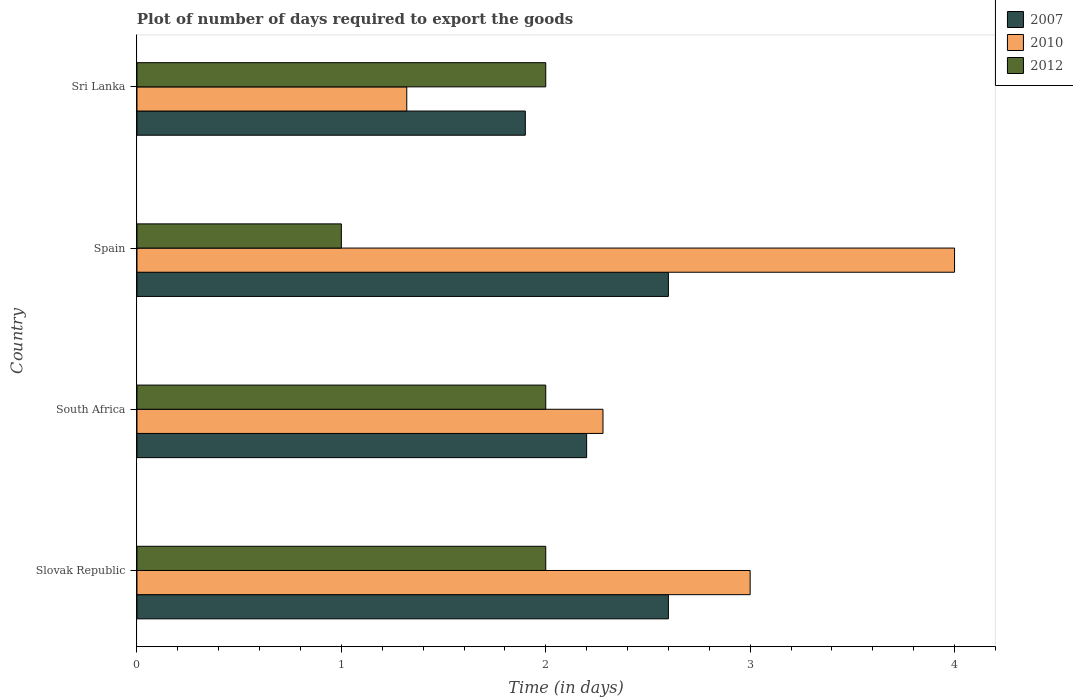How many different coloured bars are there?
Offer a terse response. 3. Are the number of bars on each tick of the Y-axis equal?
Provide a short and direct response. Yes. What is the time required to export goods in 2010 in South Africa?
Offer a very short reply. 2.28. Across all countries, what is the minimum time required to export goods in 2012?
Keep it short and to the point. 1. In which country was the time required to export goods in 2012 maximum?
Give a very brief answer. Slovak Republic. In which country was the time required to export goods in 2010 minimum?
Offer a terse response. Sri Lanka. What is the average time required to export goods in 2010 per country?
Provide a succinct answer. 2.65. In how many countries, is the time required to export goods in 2007 greater than 1.2 days?
Provide a succinct answer. 4. What is the ratio of the time required to export goods in 2007 in South Africa to that in Spain?
Provide a short and direct response. 0.85. What is the difference between the highest and the lowest time required to export goods in 2012?
Provide a succinct answer. 1. Is the sum of the time required to export goods in 2010 in South Africa and Spain greater than the maximum time required to export goods in 2012 across all countries?
Provide a succinct answer. Yes. Are all the bars in the graph horizontal?
Your answer should be compact. Yes. How many countries are there in the graph?
Ensure brevity in your answer.  4. What is the difference between two consecutive major ticks on the X-axis?
Your answer should be very brief. 1. Does the graph contain grids?
Keep it short and to the point. No. What is the title of the graph?
Provide a short and direct response. Plot of number of days required to export the goods. Does "1986" appear as one of the legend labels in the graph?
Offer a terse response. No. What is the label or title of the X-axis?
Keep it short and to the point. Time (in days). What is the Time (in days) of 2007 in Slovak Republic?
Ensure brevity in your answer.  2.6. What is the Time (in days) in 2007 in South Africa?
Offer a terse response. 2.2. What is the Time (in days) of 2010 in South Africa?
Your answer should be compact. 2.28. What is the Time (in days) in 2012 in South Africa?
Your answer should be compact. 2. What is the Time (in days) in 2007 in Sri Lanka?
Ensure brevity in your answer.  1.9. What is the Time (in days) of 2010 in Sri Lanka?
Offer a terse response. 1.32. What is the Time (in days) of 2012 in Sri Lanka?
Ensure brevity in your answer.  2. Across all countries, what is the maximum Time (in days) of 2010?
Provide a succinct answer. 4. Across all countries, what is the minimum Time (in days) of 2010?
Provide a succinct answer. 1.32. Across all countries, what is the minimum Time (in days) of 2012?
Your response must be concise. 1. What is the total Time (in days) of 2012 in the graph?
Make the answer very short. 7. What is the difference between the Time (in days) of 2007 in Slovak Republic and that in South Africa?
Provide a short and direct response. 0.4. What is the difference between the Time (in days) in 2010 in Slovak Republic and that in South Africa?
Your response must be concise. 0.72. What is the difference between the Time (in days) of 2010 in Slovak Republic and that in Sri Lanka?
Provide a short and direct response. 1.68. What is the difference between the Time (in days) in 2012 in Slovak Republic and that in Sri Lanka?
Give a very brief answer. 0. What is the difference between the Time (in days) in 2007 in South Africa and that in Spain?
Your answer should be compact. -0.4. What is the difference between the Time (in days) in 2010 in South Africa and that in Spain?
Your answer should be very brief. -1.72. What is the difference between the Time (in days) of 2007 in South Africa and that in Sri Lanka?
Your answer should be compact. 0.3. What is the difference between the Time (in days) of 2010 in Spain and that in Sri Lanka?
Offer a very short reply. 2.68. What is the difference between the Time (in days) of 2012 in Spain and that in Sri Lanka?
Provide a succinct answer. -1. What is the difference between the Time (in days) in 2007 in Slovak Republic and the Time (in days) in 2010 in South Africa?
Offer a terse response. 0.32. What is the difference between the Time (in days) of 2007 in Slovak Republic and the Time (in days) of 2012 in South Africa?
Provide a short and direct response. 0.6. What is the difference between the Time (in days) of 2010 in Slovak Republic and the Time (in days) of 2012 in South Africa?
Offer a terse response. 1. What is the difference between the Time (in days) in 2010 in Slovak Republic and the Time (in days) in 2012 in Spain?
Offer a very short reply. 2. What is the difference between the Time (in days) of 2007 in Slovak Republic and the Time (in days) of 2010 in Sri Lanka?
Offer a very short reply. 1.28. What is the difference between the Time (in days) in 2007 in South Africa and the Time (in days) in 2010 in Spain?
Provide a succinct answer. -1.8. What is the difference between the Time (in days) of 2010 in South Africa and the Time (in days) of 2012 in Spain?
Your answer should be compact. 1.28. What is the difference between the Time (in days) in 2007 in South Africa and the Time (in days) in 2010 in Sri Lanka?
Give a very brief answer. 0.88. What is the difference between the Time (in days) of 2007 in South Africa and the Time (in days) of 2012 in Sri Lanka?
Your answer should be compact. 0.2. What is the difference between the Time (in days) of 2010 in South Africa and the Time (in days) of 2012 in Sri Lanka?
Your answer should be compact. 0.28. What is the difference between the Time (in days) in 2007 in Spain and the Time (in days) in 2010 in Sri Lanka?
Keep it short and to the point. 1.28. What is the difference between the Time (in days) of 2007 in Spain and the Time (in days) of 2012 in Sri Lanka?
Your answer should be very brief. 0.6. What is the average Time (in days) in 2007 per country?
Your response must be concise. 2.33. What is the average Time (in days) of 2010 per country?
Offer a very short reply. 2.65. What is the difference between the Time (in days) of 2007 and Time (in days) of 2010 in Slovak Republic?
Provide a succinct answer. -0.4. What is the difference between the Time (in days) of 2007 and Time (in days) of 2010 in South Africa?
Ensure brevity in your answer.  -0.08. What is the difference between the Time (in days) of 2007 and Time (in days) of 2012 in South Africa?
Give a very brief answer. 0.2. What is the difference between the Time (in days) of 2010 and Time (in days) of 2012 in South Africa?
Your answer should be compact. 0.28. What is the difference between the Time (in days) in 2007 and Time (in days) in 2012 in Spain?
Provide a succinct answer. 1.6. What is the difference between the Time (in days) in 2007 and Time (in days) in 2010 in Sri Lanka?
Ensure brevity in your answer.  0.58. What is the difference between the Time (in days) in 2010 and Time (in days) in 2012 in Sri Lanka?
Make the answer very short. -0.68. What is the ratio of the Time (in days) in 2007 in Slovak Republic to that in South Africa?
Your answer should be compact. 1.18. What is the ratio of the Time (in days) in 2010 in Slovak Republic to that in South Africa?
Offer a terse response. 1.32. What is the ratio of the Time (in days) in 2012 in Slovak Republic to that in South Africa?
Offer a very short reply. 1. What is the ratio of the Time (in days) of 2010 in Slovak Republic to that in Spain?
Provide a short and direct response. 0.75. What is the ratio of the Time (in days) in 2012 in Slovak Republic to that in Spain?
Offer a very short reply. 2. What is the ratio of the Time (in days) of 2007 in Slovak Republic to that in Sri Lanka?
Your response must be concise. 1.37. What is the ratio of the Time (in days) of 2010 in Slovak Republic to that in Sri Lanka?
Your response must be concise. 2.27. What is the ratio of the Time (in days) of 2007 in South Africa to that in Spain?
Your answer should be very brief. 0.85. What is the ratio of the Time (in days) in 2010 in South Africa to that in Spain?
Provide a succinct answer. 0.57. What is the ratio of the Time (in days) in 2007 in South Africa to that in Sri Lanka?
Offer a terse response. 1.16. What is the ratio of the Time (in days) of 2010 in South Africa to that in Sri Lanka?
Provide a short and direct response. 1.73. What is the ratio of the Time (in days) of 2007 in Spain to that in Sri Lanka?
Keep it short and to the point. 1.37. What is the ratio of the Time (in days) in 2010 in Spain to that in Sri Lanka?
Your response must be concise. 3.03. What is the difference between the highest and the second highest Time (in days) in 2007?
Provide a succinct answer. 0. What is the difference between the highest and the second highest Time (in days) of 2012?
Your response must be concise. 0. What is the difference between the highest and the lowest Time (in days) in 2010?
Keep it short and to the point. 2.68. What is the difference between the highest and the lowest Time (in days) in 2012?
Your answer should be compact. 1. 